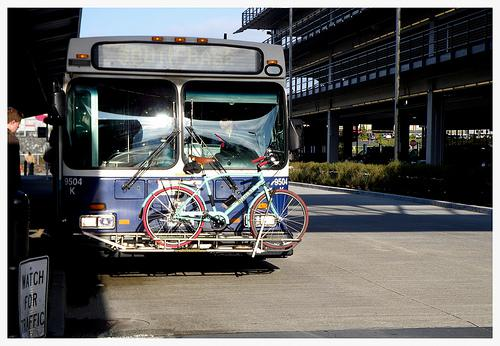Question: what is on the front of the bus?
Choices:
A. A sign.
B. A scooter.
C. A license plate.
D. A bicycle.
Answer with the letter. Answer: D Question: why did the bus stop?
Choices:
A. For a stop sign.
B. For pedestrians.
C. For a stop light.
D. To pick up people.
Answer with the letter. Answer: D Question: who is getting on the bus?
Choices:
A. A child with his friends.
B. A woman and a child.
C. A man in a black shirt.
D. A man in a suit.
Answer with the letter. Answer: C Question: when will the bus move?
Choices:
A. When the traffic moves.
B. When the light turns green.
C. When the door closes.
D. When the people stop boarding.
Answer with the letter. Answer: D 